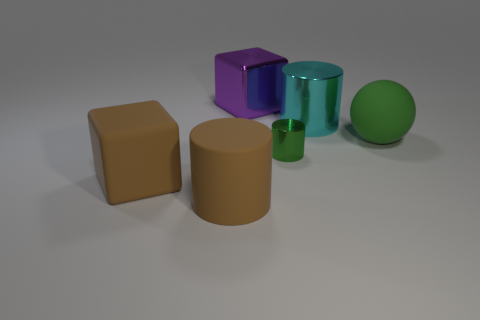How many other things are there of the same color as the tiny cylinder?
Your answer should be compact. 1. There is a cylinder that is the same color as the rubber block; what is it made of?
Your answer should be compact. Rubber. There is a brown object that is the same shape as the cyan shiny thing; what material is it?
Provide a short and direct response. Rubber. There is a tiny object; does it have the same color as the rubber thing on the right side of the green cylinder?
Make the answer very short. Yes. Are there any other things that are the same size as the green metallic thing?
Offer a terse response. No. Do the large shiny thing that is on the left side of the big cyan thing and the small shiny thing have the same shape?
Your answer should be very brief. No. How many large objects are on the right side of the metallic cylinder on the left side of the big cyan metal cylinder?
Provide a short and direct response. 2. What number of other objects are the same shape as the big purple object?
Your answer should be very brief. 1. What number of objects are tiny metal spheres or metallic things on the right side of the purple metallic block?
Offer a terse response. 2. Is the number of cubes behind the cyan thing greater than the number of brown matte things behind the big green ball?
Provide a short and direct response. Yes. 